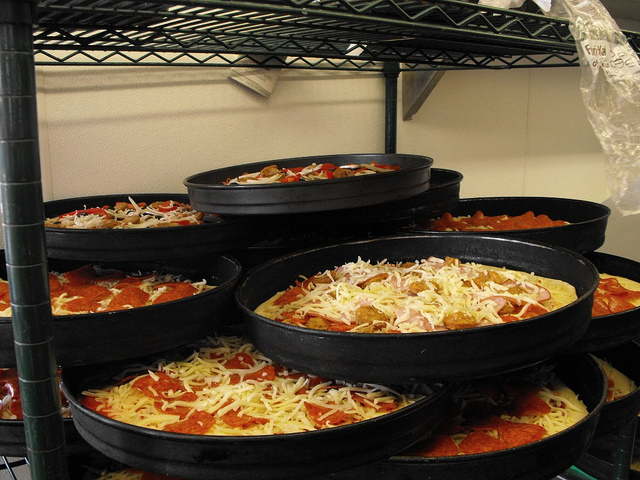Describe in detail the process illustrated by the arrangement of pizzas in the image. The image showcases a series of pizza pans stacked vertically, each filled with pizzas at various stages of preparation. Starting from the bottom, the pizzas are more covered in toppings and appear closer to being fully prepared, while those higher up seem to have just the basic layer of sauce and are in the early stages of topping application. This arrangement suggests a workflow where pizzas are prepared in batches and moved upwards as they complete early stages of preparation. 